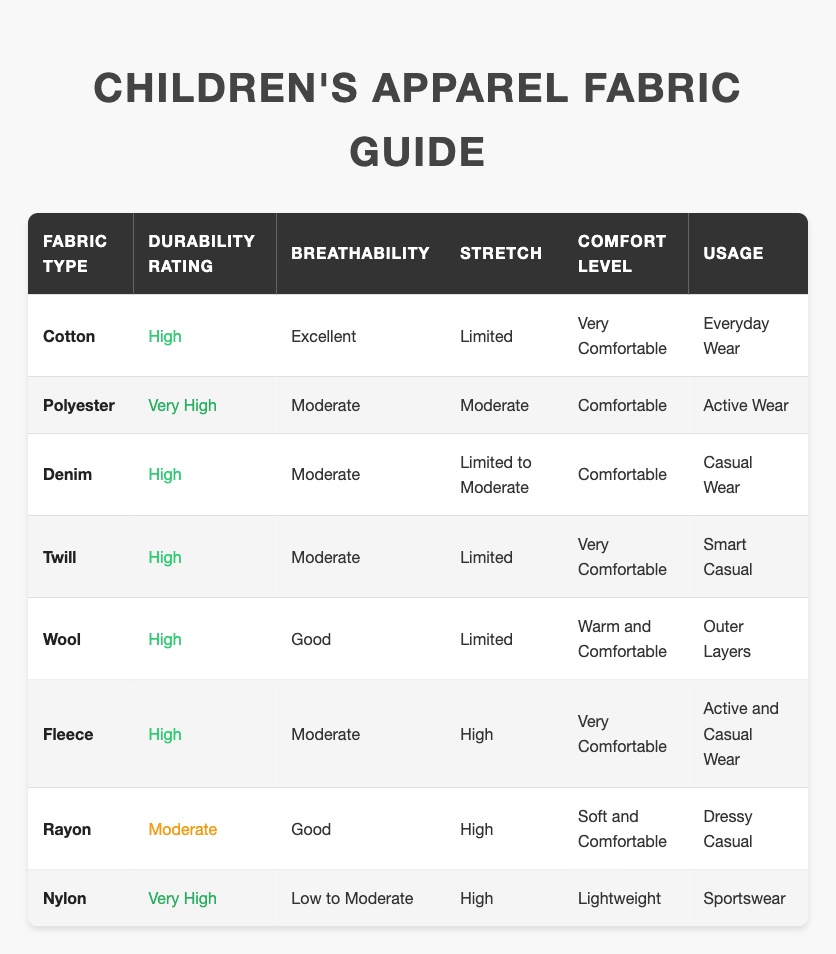What is the durability rating of Cotton? The table shows the durability rating for Cotton, which is listed directly in the "Durability Rating" column. It states "High" for Cotton.
Answer: High Which fabric type is rated "Very High" for durability? By looking at the "Durability Rating" column, there are two fabric types with a "Very High" rating: Polyester and Nylon.
Answer: Polyester, Nylon What fabric type is best for everyday wear based on the table? The "Usage" column indicates that Cotton is designated for "Everyday Wear," making it the best option for this purpose.
Answer: Cotton Is Rayon considered a durable fabric in children's apparel? Checking the "Durability Rating" for Rayon, it is rated as "Moderate," which indicates it is not highly durable.
Answer: No Which fabric has the highest comfort level, and what is that level? The table shows Fleece and Cotton both rated as "Very Comfortable." However, Fleece is listed as the most comfortable fabric due to its additional characteristics.
Answer: Fleece, Very Comfortable How many fabric types have a "High" durability rating? Reviewing the "Durability Rating" column, there are five fabric types (Cotton, Denim, Twill, Wool, Fleece) marked with a "High" durability rating.
Answer: Five Which fabric types have moderate breathability? The "Breathability" column shows that Polyester, Denim, Twill, Fleece, and Rayon are rated as "Moderate," indicating a balance between airflow and protection.
Answer: Polyester, Denim, Twill, Fleece, Rayon For which type of usage is Nylon recommended? The table specifies in the "Usage" column that Nylon is associated with "Sportswear," indicating it's suitable for this type of activity.
Answer: Sportswear What is the stretch capability of Wool? Referring to the "Stretch" column, Wool is shown to have "Limited" stretch capability, which means it does not stretch much.
Answer: Limited Which fabric has the best breathability, and how is it rated? The table highlights that Cotton has an "Excellent" breathability rating, indicating its superior ability to allow airflow.
Answer: Cotton, Excellent How many fabrics are suitable for active wear? From the table, the fabrics categorized for active wear are Polyester and Fleece. This totals to two suitable fabric types.
Answer: Two 